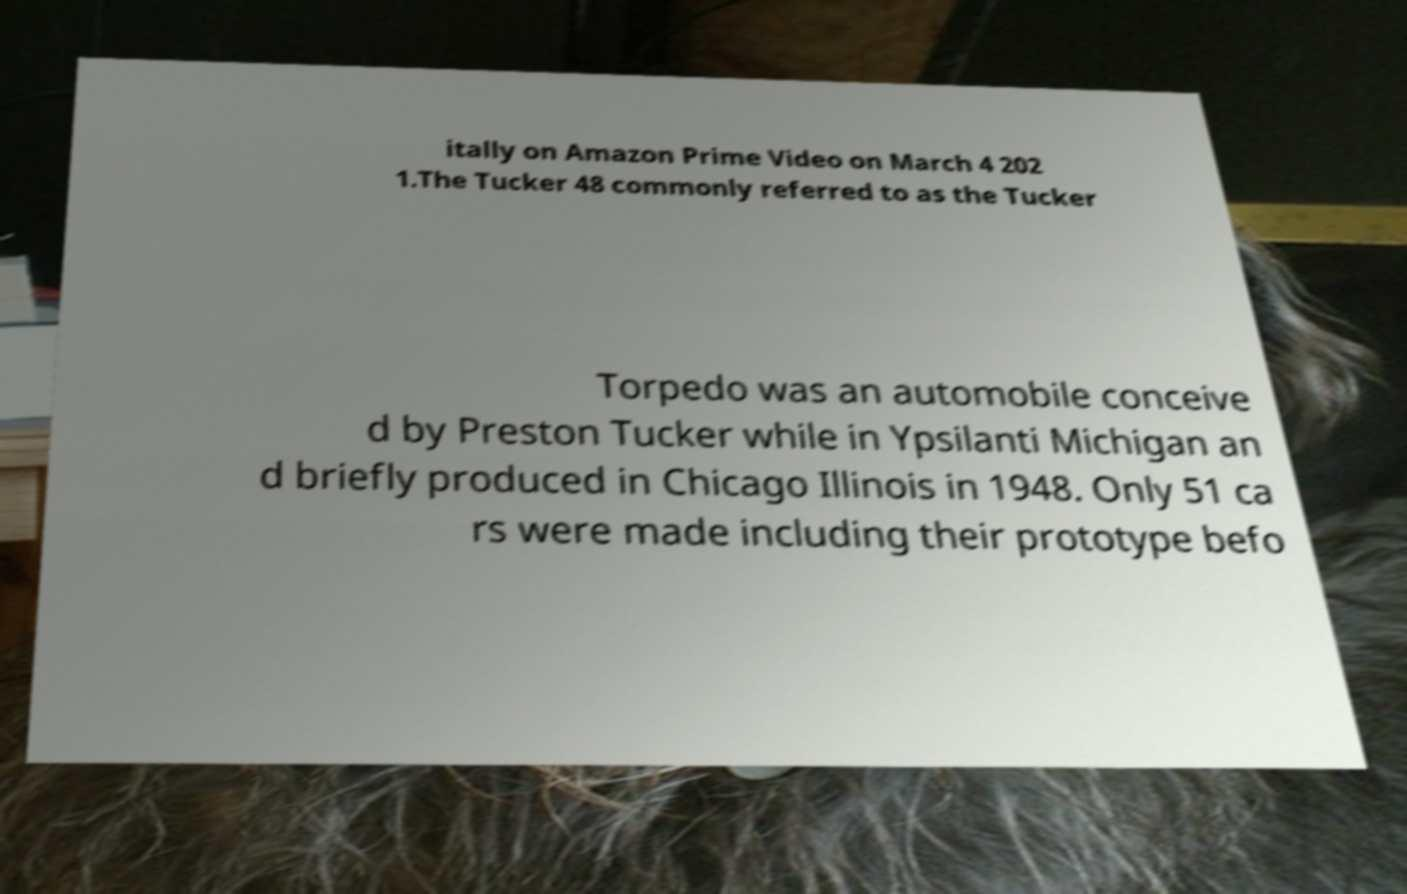Please identify and transcribe the text found in this image. itally on Amazon Prime Video on March 4 202 1.The Tucker 48 commonly referred to as the Tucker Torpedo was an automobile conceive d by Preston Tucker while in Ypsilanti Michigan an d briefly produced in Chicago Illinois in 1948. Only 51 ca rs were made including their prototype befo 